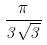Convert formula to latex. <formula><loc_0><loc_0><loc_500><loc_500>\frac { \pi } { 3 \sqrt { 3 } }</formula> 